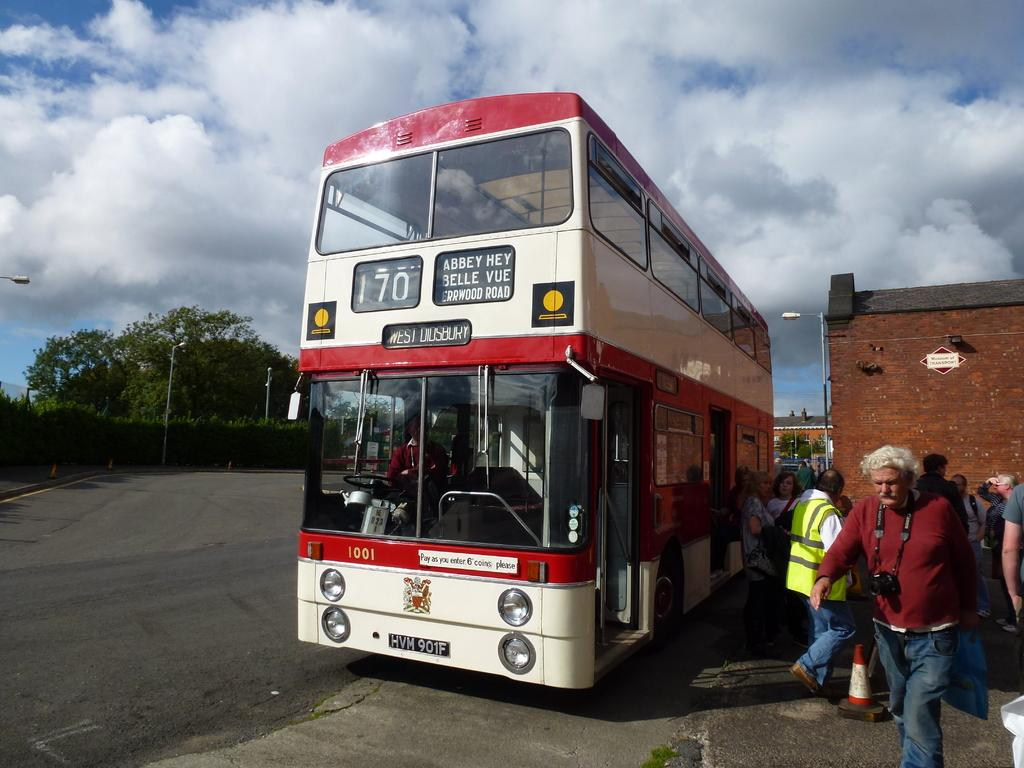Provide a one-sentence caption for the provided image. double decker bus that read number 170 with people at the bottom. 